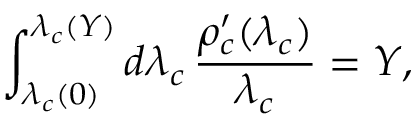<formula> <loc_0><loc_0><loc_500><loc_500>\int _ { \lambda _ { c } ( 0 ) } ^ { \lambda _ { c } ( Y ) } d \lambda _ { c } \, \frac { \rho _ { c } ^ { \prime } ( \lambda _ { c } ) } { \lambda _ { c } } = Y ,</formula> 